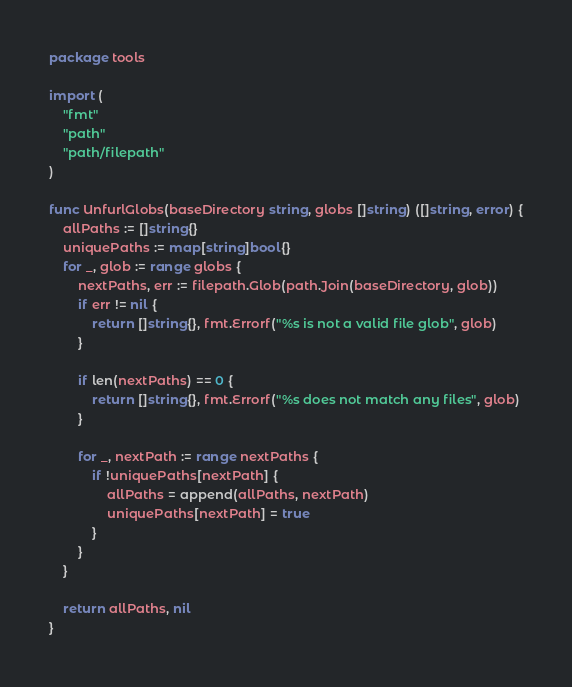<code> <loc_0><loc_0><loc_500><loc_500><_Go_>package tools

import (
	"fmt"
	"path"
	"path/filepath"
)

func UnfurlGlobs(baseDirectory string, globs []string) ([]string, error) {
	allPaths := []string{}
	uniquePaths := map[string]bool{}
	for _, glob := range globs {
		nextPaths, err := filepath.Glob(path.Join(baseDirectory, glob))
		if err != nil {
			return []string{}, fmt.Errorf("%s is not a valid file glob", glob)
		}

		if len(nextPaths) == 0 {
			return []string{}, fmt.Errorf("%s does not match any files", glob)
		}

		for _, nextPath := range nextPaths {
			if !uniquePaths[nextPath] {
				allPaths = append(allPaths, nextPath)
				uniquePaths[nextPath] = true
			}
		}
	}

	return allPaths, nil
}
</code> 